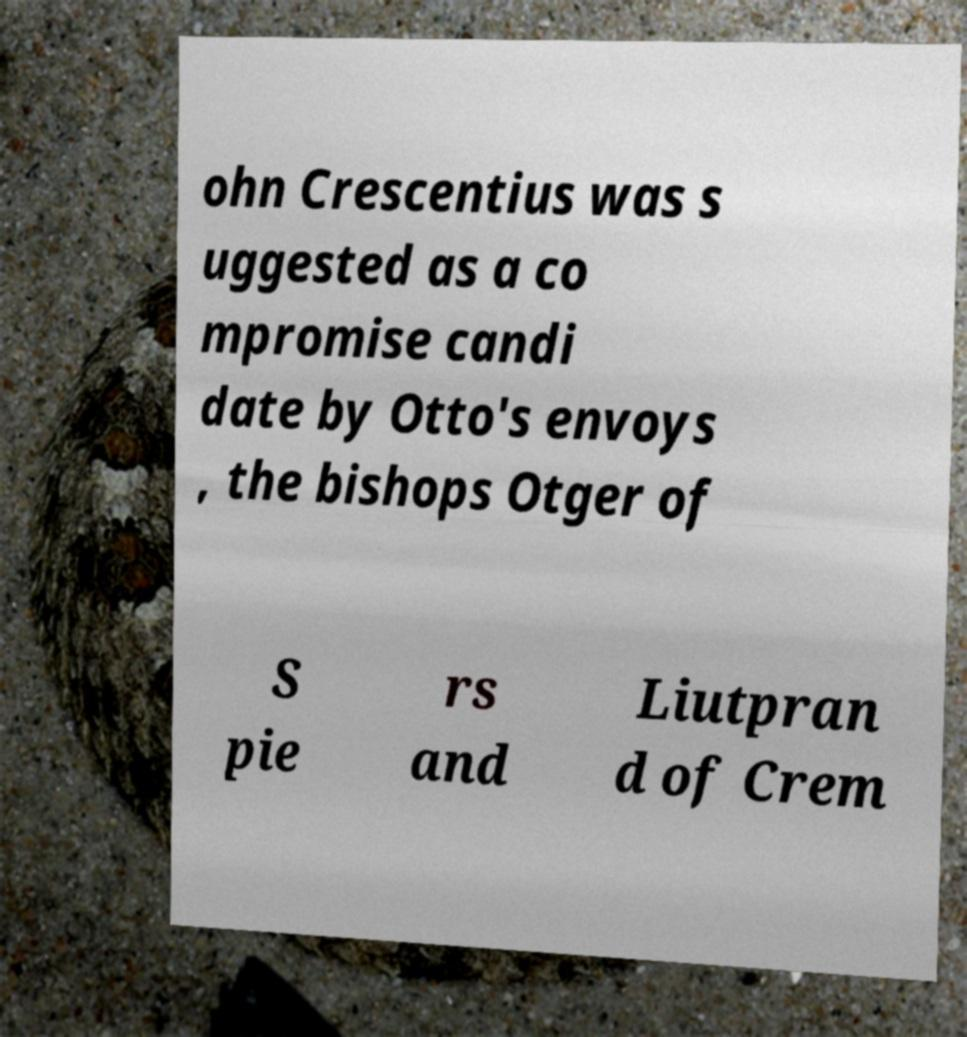Could you assist in decoding the text presented in this image and type it out clearly? ohn Crescentius was s uggested as a co mpromise candi date by Otto's envoys , the bishops Otger of S pie rs and Liutpran d of Crem 